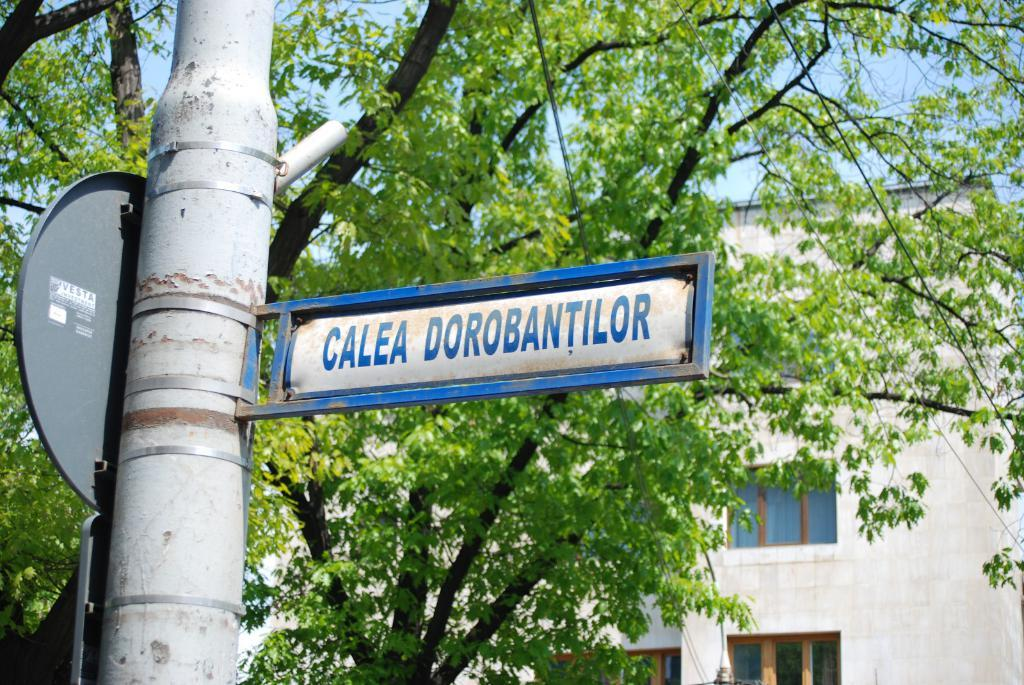<image>
Present a compact description of the photo's key features. A street sign that reads "Calea Dorobantilor" in front of a tree and building. 